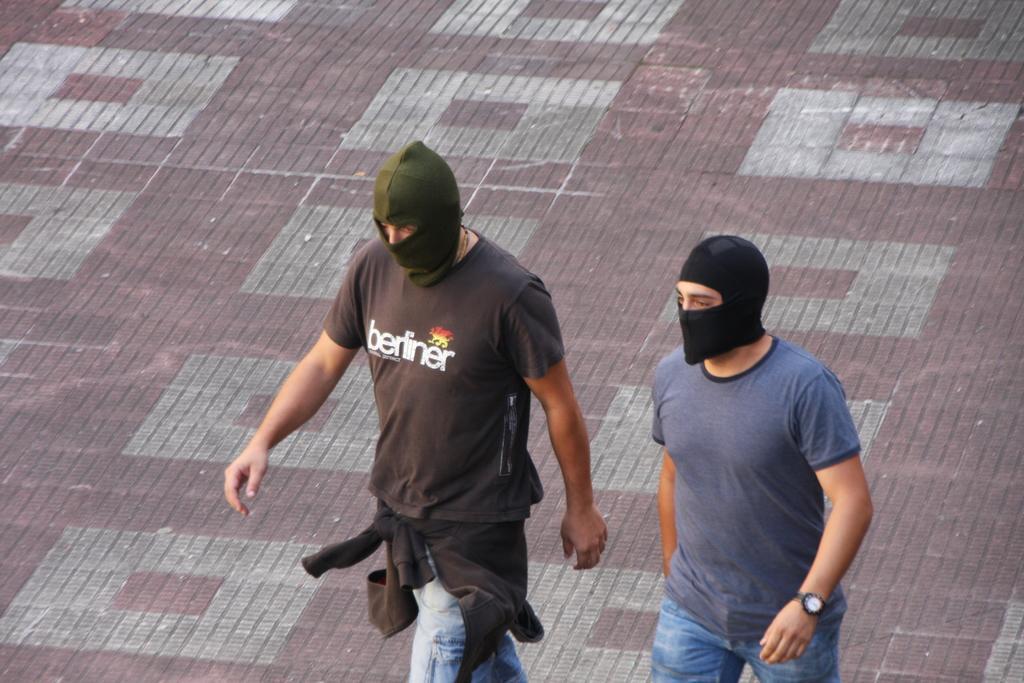Please provide a concise description of this image. In the image on the floor there are two men with masks are walking. 